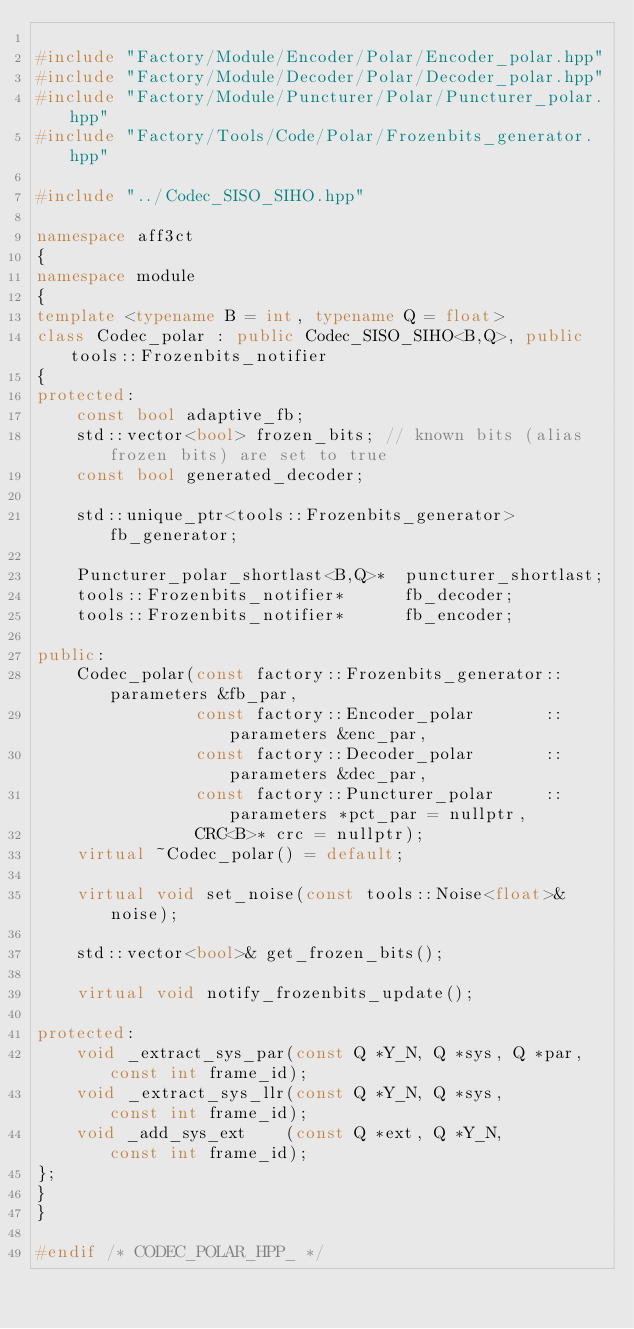Convert code to text. <code><loc_0><loc_0><loc_500><loc_500><_C++_>
#include "Factory/Module/Encoder/Polar/Encoder_polar.hpp"
#include "Factory/Module/Decoder/Polar/Decoder_polar.hpp"
#include "Factory/Module/Puncturer/Polar/Puncturer_polar.hpp"
#include "Factory/Tools/Code/Polar/Frozenbits_generator.hpp"

#include "../Codec_SISO_SIHO.hpp"

namespace aff3ct
{
namespace module
{
template <typename B = int, typename Q = float>
class Codec_polar : public Codec_SISO_SIHO<B,Q>, public tools::Frozenbits_notifier
{
protected:
	const bool adaptive_fb;
	std::vector<bool> frozen_bits; // known bits (alias frozen bits) are set to true
	const bool generated_decoder;

	std::unique_ptr<tools::Frozenbits_generator>    fb_generator;

	Puncturer_polar_shortlast<B,Q>*  puncturer_shortlast;
	tools::Frozenbits_notifier*      fb_decoder;
	tools::Frozenbits_notifier*      fb_encoder;

public:
	Codec_polar(const factory::Frozenbits_generator::parameters &fb_par,
	            const factory::Encoder_polar       ::parameters &enc_par,
	            const factory::Decoder_polar       ::parameters &dec_par,
	            const factory::Puncturer_polar     ::parameters *pct_par = nullptr,
	            CRC<B>* crc = nullptr);
	virtual ~Codec_polar() = default;

	virtual void set_noise(const tools::Noise<float>& noise);

	std::vector<bool>& get_frozen_bits();

	virtual void notify_frozenbits_update();

protected:
	void _extract_sys_par(const Q *Y_N, Q *sys, Q *par, const int frame_id);
	void _extract_sys_llr(const Q *Y_N, Q *sys,         const int frame_id);
	void _add_sys_ext    (const Q *ext, Q *Y_N,         const int frame_id);
};
}
}

#endif /* CODEC_POLAR_HPP_ */
</code> 